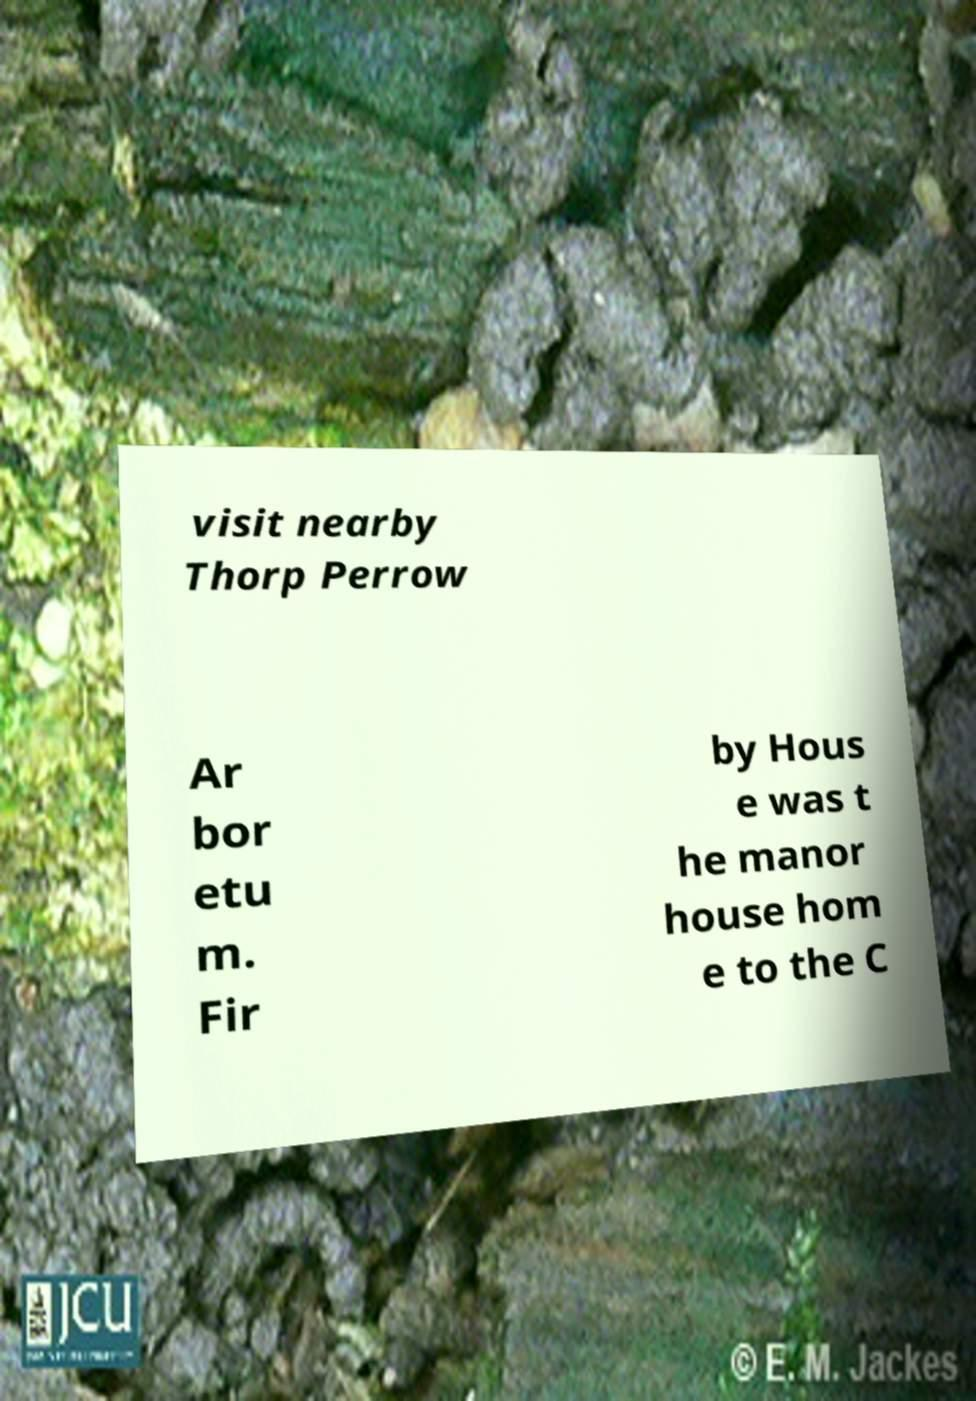Could you extract and type out the text from this image? visit nearby Thorp Perrow Ar bor etu m. Fir by Hous e was t he manor house hom e to the C 